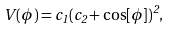<formula> <loc_0><loc_0><loc_500><loc_500>V ( \phi ) = c _ { 1 } ( c _ { 2 } + \cos [ \phi ] ) ^ { 2 } ,</formula> 